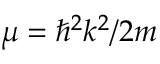<formula> <loc_0><loc_0><loc_500><loc_500>\mu = \hbar { ^ } { 2 } k ^ { 2 } / 2 m</formula> 